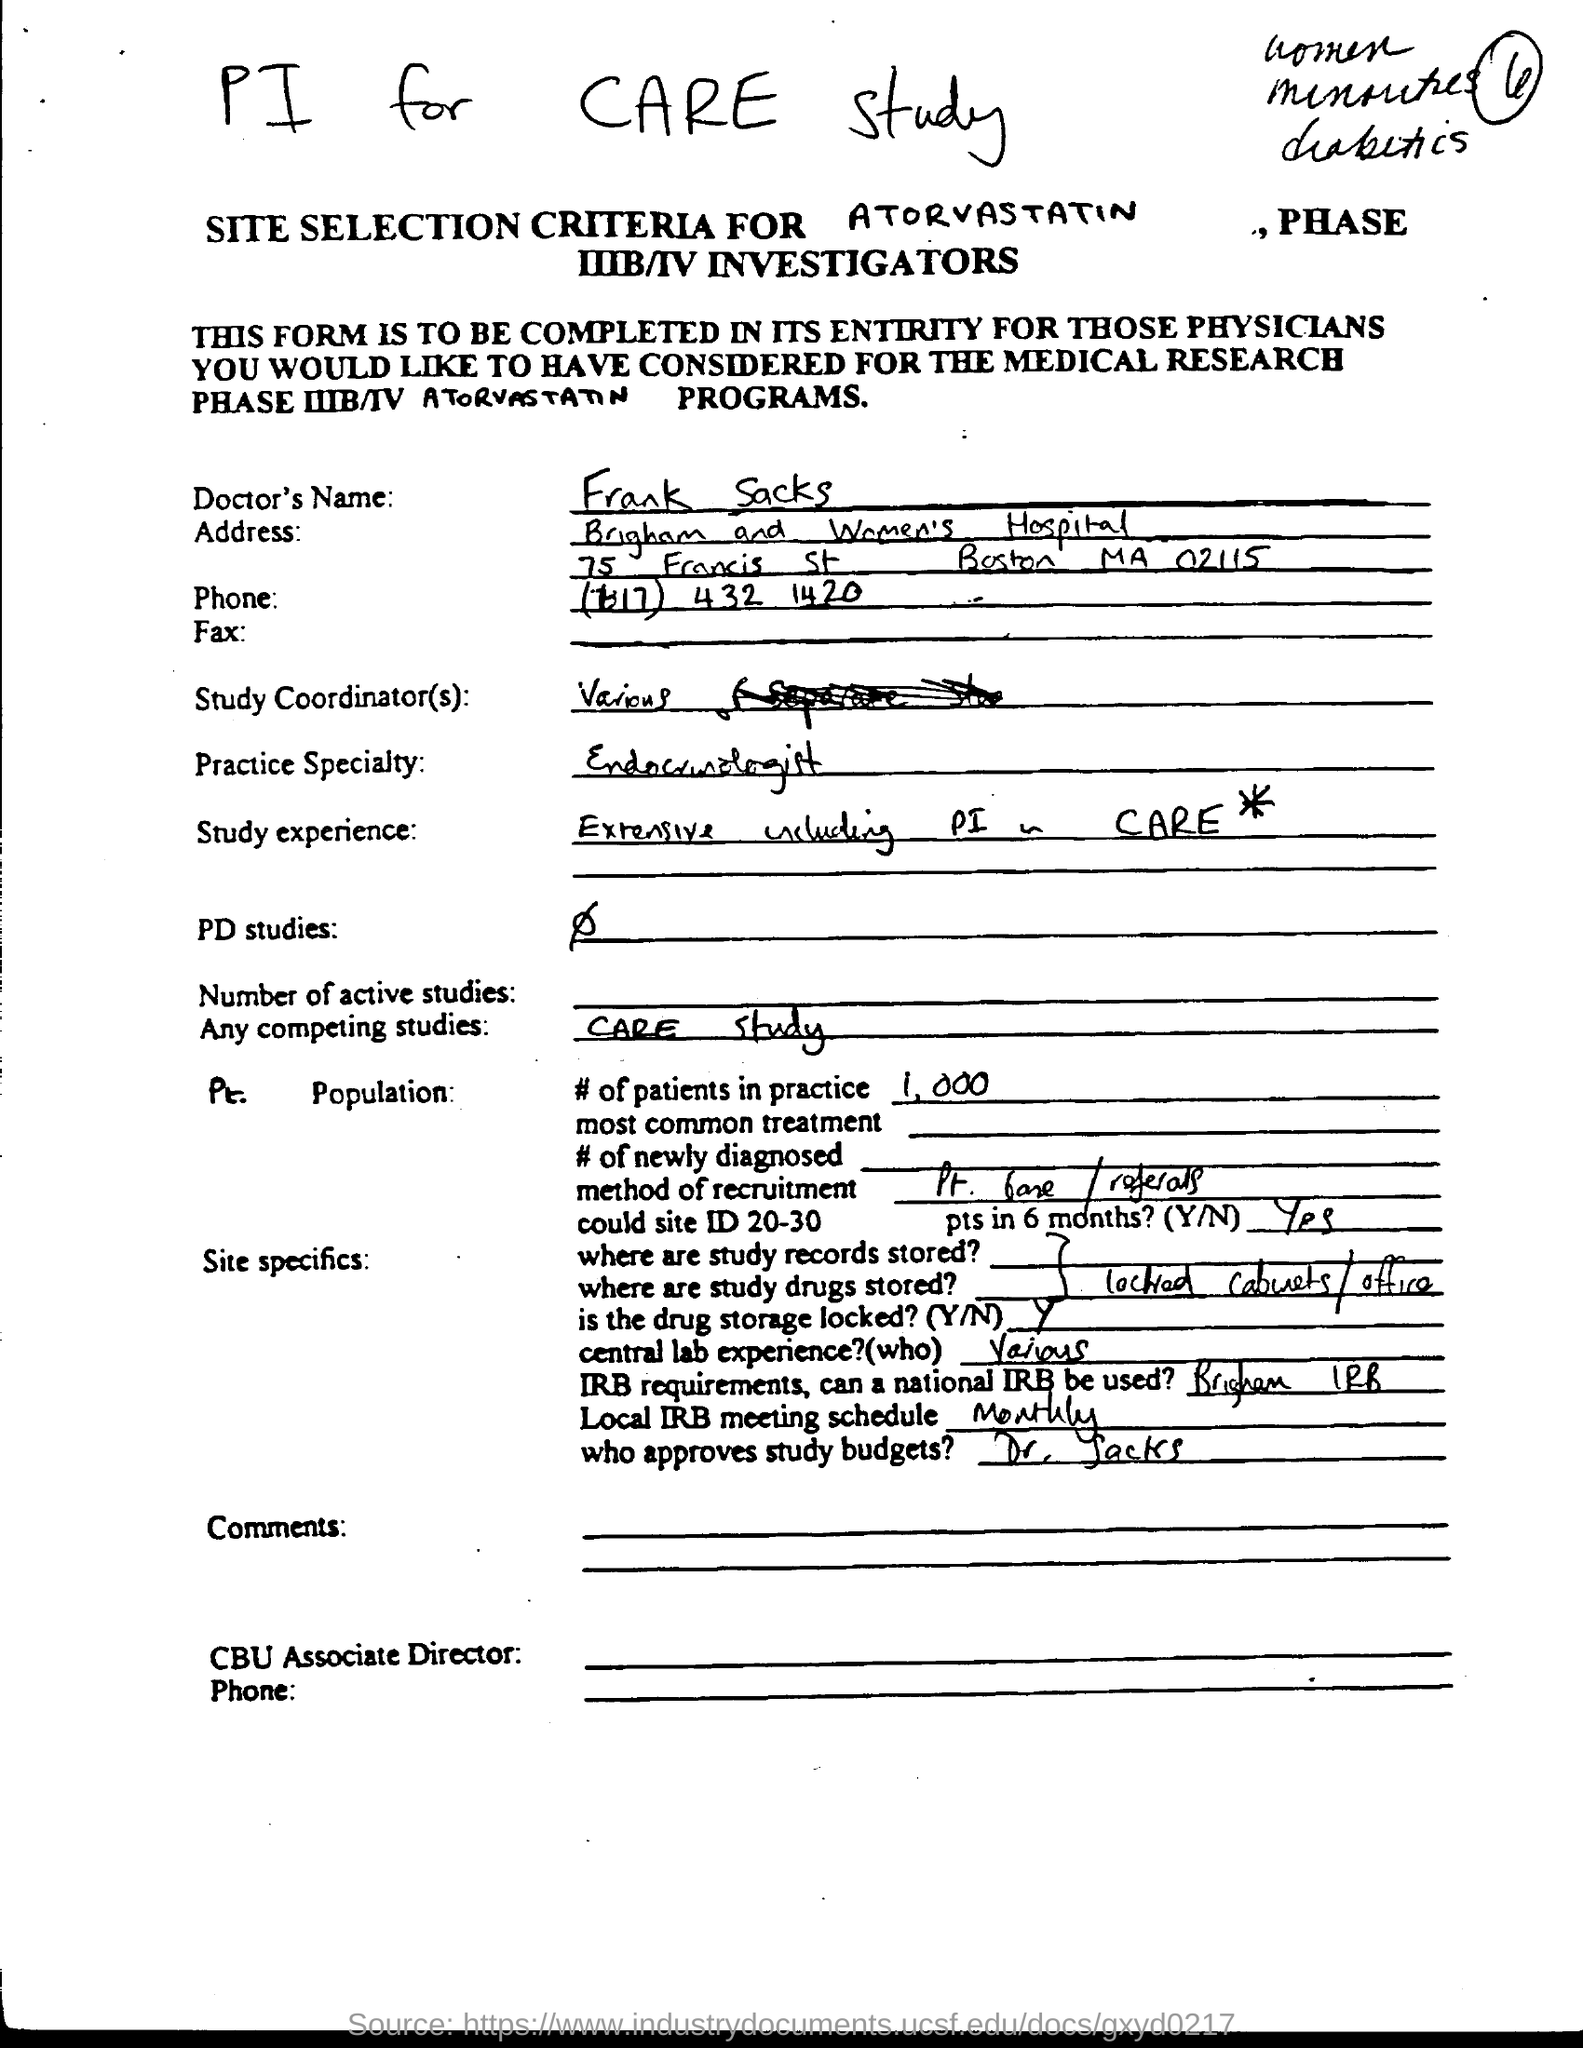Who approves study budgets?
Provide a succinct answer. Dr. sacks. What is the Doctor's Name?
Keep it short and to the point. Frank Sacks. What is the Doctor's Practice Specialty?
Offer a terse response. Endocrinologist. 